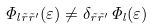Convert formula to latex. <formula><loc_0><loc_0><loc_500><loc_500>\Phi _ { l \tilde { r } \tilde { r } ^ { \prime } } ( \varepsilon ) \neq \delta _ { \tilde { r } \tilde { r } ^ { \prime } } \Phi _ { l } ( \varepsilon )</formula> 